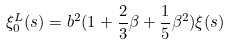Convert formula to latex. <formula><loc_0><loc_0><loc_500><loc_500>\xi ^ { L } _ { 0 } ( s ) = b ^ { 2 } ( 1 + \frac { 2 } { 3 } \beta + \frac { 1 } { 5 } \beta ^ { 2 } ) \xi ( s )</formula> 